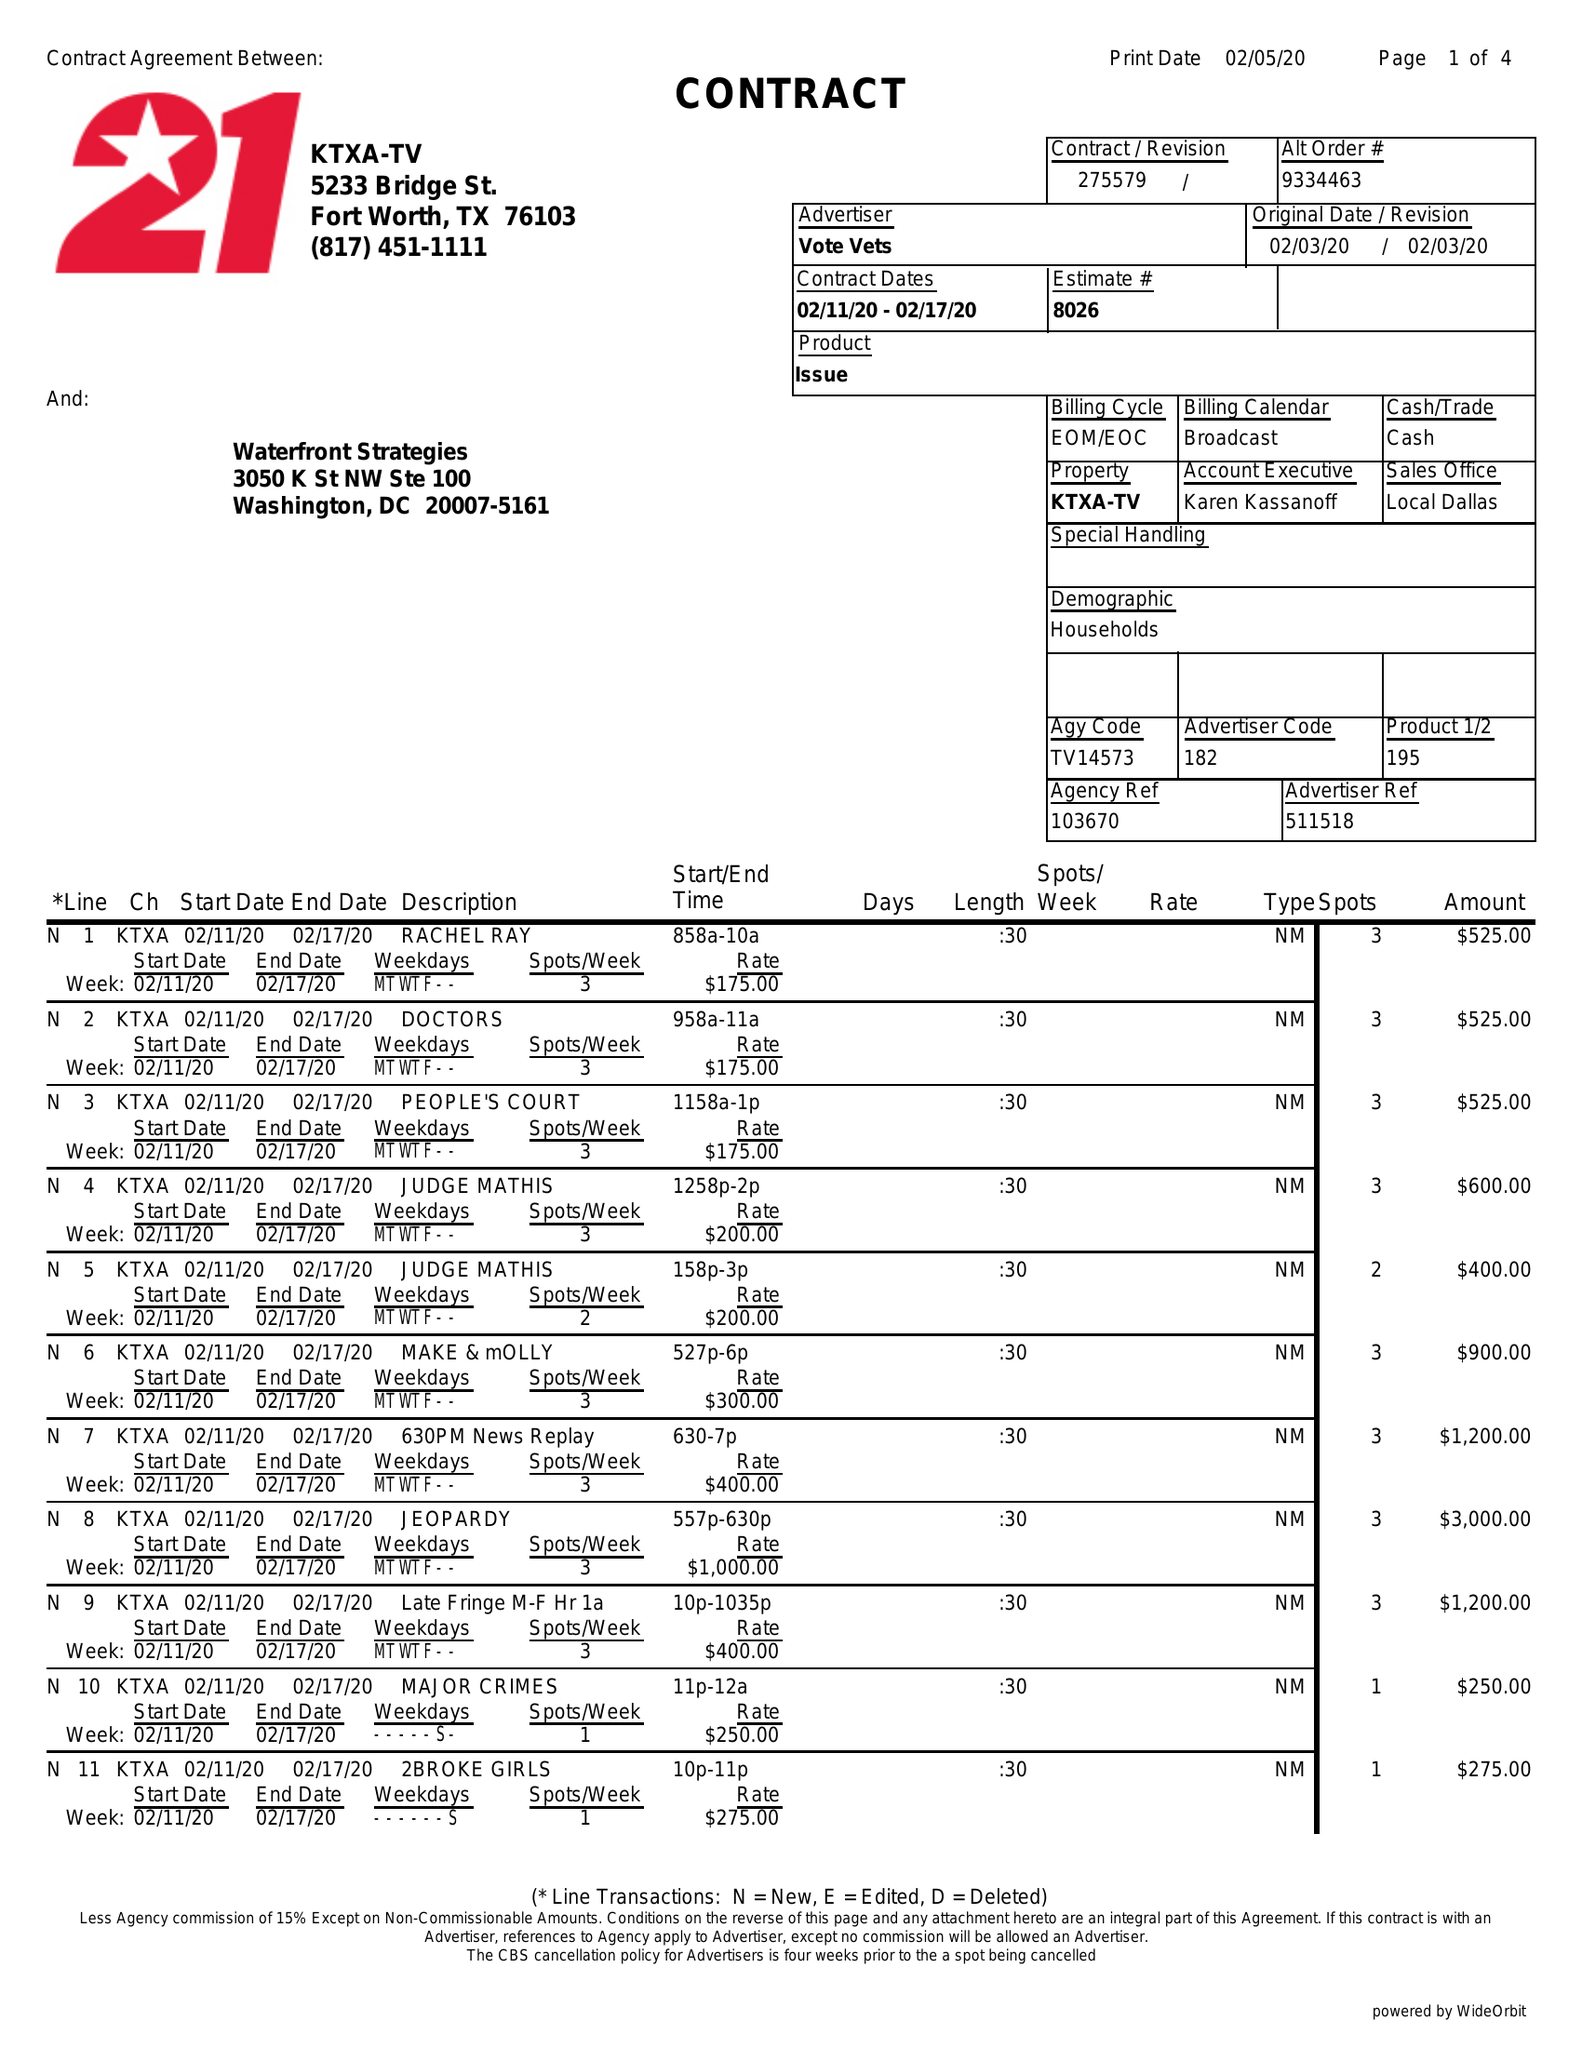What is the value for the gross_amount?
Answer the question using a single word or phrase. 10250.00 